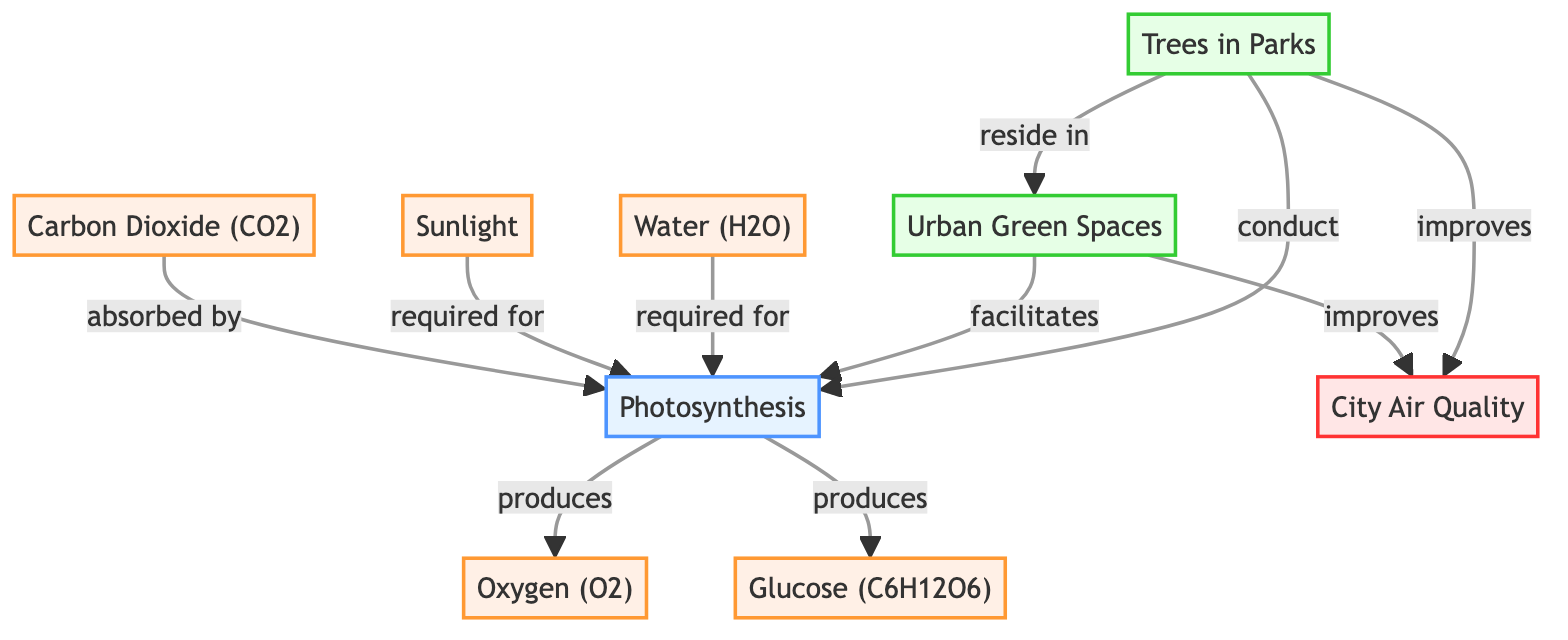What is produced during photosynthesis? According to the diagram, the process of photosynthesis results in the production of two key elements: oxygen and glucose. Both are shown as outputs connected to the photosynthesis node.
Answer: Oxygen and glucose How many main components are required for photosynthesis? The diagram identifies three main components involved in photosynthesis, which are carbon dioxide, sunlight, and water. I can see these three elements connecting to the photosynthesis process node.
Answer: Three What role do trees in parks play in urban green spaces? The diagram indicates that trees in parks reside within urban green spaces and are active participants in conducting photosynthesis. This shows their role as essential components in these environments.
Answer: Conduct photosynthesis What is the relationship between urban green spaces and city air quality? The diagram outlines that urban green spaces facilitate photosynthesis, which leads to an improvement in city air quality. This connection highlights how urban green spaces contribute positively to the environment.
Answer: Improves city air quality What is the function of sunlight in the process shown in the diagram? The diagram illustrates that sunlight is a required element for photosynthesis. This suggests that without sunlight, photosynthesis could not occur, impacting the overall process.
Answer: Required for photosynthesis How do urban green spaces affect the quality of air in cities? In the diagram, urban green spaces are shown to facilitate photosynthesis, which ultimately improves city air quality. This indicates a direct positive influence of green spaces on air quality.
Answer: Improves city air quality What substance is absorbed by photosynthesis? The diagram specifies that carbon dioxide, also represented as CO2, is absorbed by the process of photosynthesis, indicating its use in creating other outputs like glucose and oxygen.
Answer: Carbon Dioxide (CO2) What are the outcomes of photosynthesis according to the diagram? The outcomes of photosynthesis, as shown in the diagram, include the production of oxygen and glucose. These two substances represent the results of this biological process.
Answer: Oxygen and glucose 